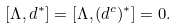<formula> <loc_0><loc_0><loc_500><loc_500>[ \Lambda , d ^ { * } ] = [ \Lambda , ( d ^ { c } ) ^ { * } ] = 0 .</formula> 